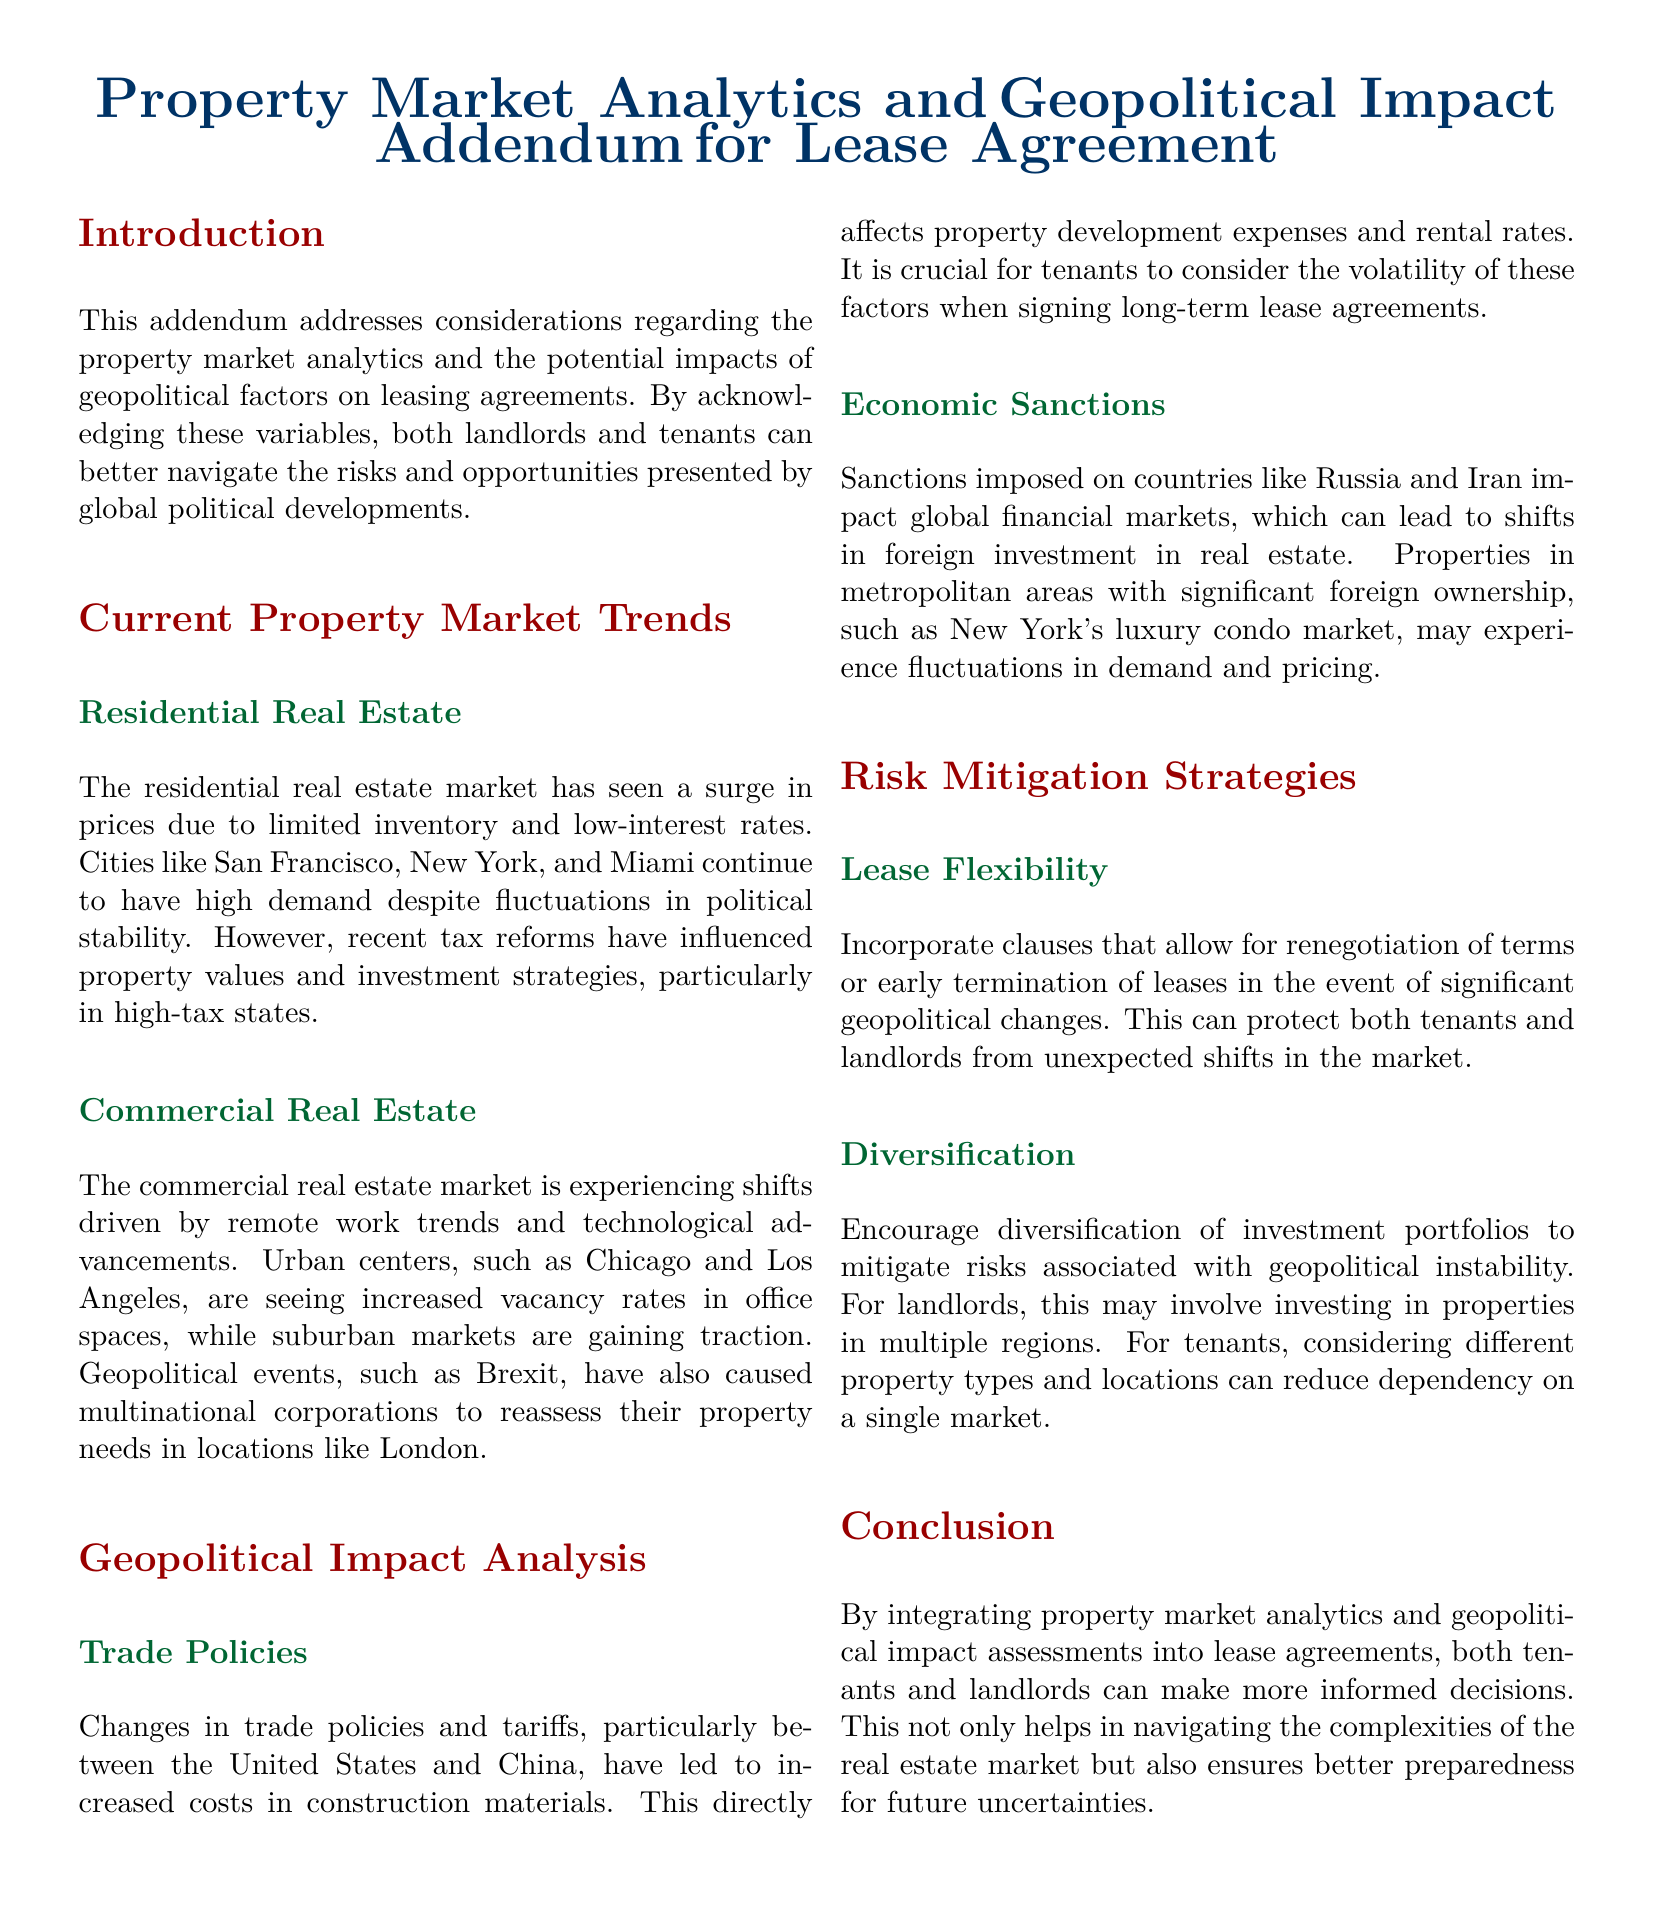What is addressed in the addendum? The addendum addresses considerations regarding property market analytics and the potential impacts of geopolitical factors on leasing agreements.
Answer: Property market analytics and geopolitical factors Which cities are mentioned in the residential real estate section? The cities mentioned are San Francisco, New York, and Miami.
Answer: San Francisco, New York, Miami What are the two factors influencing the commercial real estate market? The factors influencing the commercial real estate market are remote work trends and technological advancements.
Answer: Remote work trends and technological advancements Why should tenants consider the volatility of trade policies? Because changes in trade policies and tariffs lead to increased costs in construction materials, affecting rental rates.
Answer: Increased costs in construction materials What is a recommended strategy for landlords regarding investment? It is recommended that landlords invest in properties in multiple regions to encourage diversification and mitigate risks.
Answer: Invest in properties in multiple regions What geopolitical event affected multinational corporations' property needs? The geopolitical event that affected multinational corporations' property needs is Brexit.
Answer: Brexit How can lease flexibility benefit both tenants and landlords? Lease flexibility can protect both parties from unexpected shifts in the market due to significant geopolitical changes.
Answer: Protect from unexpected shifts in the market What impact do economic sanctions have on metropolitan areas? Economic sanctions can lead to shifts in foreign investment in real estate, affecting demand and pricing in areas with significant foreign ownership.
Answer: Shifts in foreign investment in real estate What should be incorporated into leases in response to geopolitical changes? Clauses that allow for renegotiation of terms or early termination of leases should be incorporated into leases.
Answer: Renegotiation clauses or early termination 